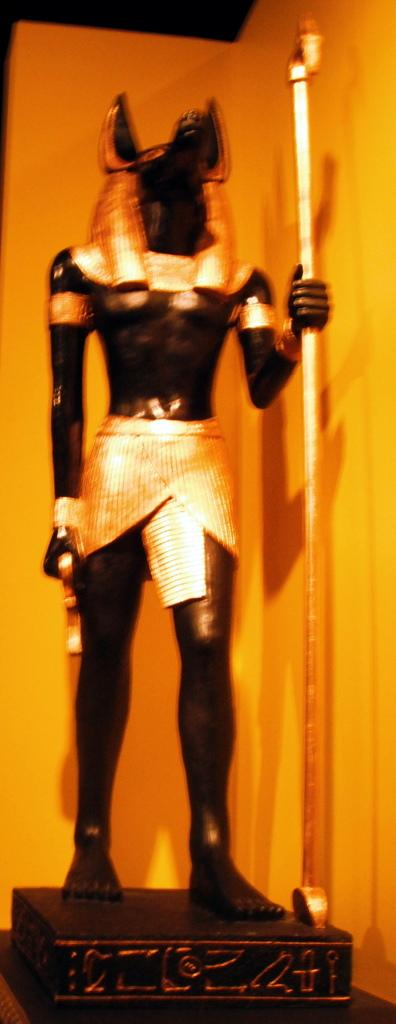What is the main subject of the image? There is a black color sculpture in the image. Can you describe the quality of the image? The image is a little bit blurry. What is the sculpture holding in the image? The sculpture is holding a rod. How many lizards can be seen crawling on the sculpture in the image? There are no lizards present in the image; it features a black color sculpture holding a rod. What type of hand is holding the rod in the image? There is no hand visible in the image, as the sculpture is not a living being. 